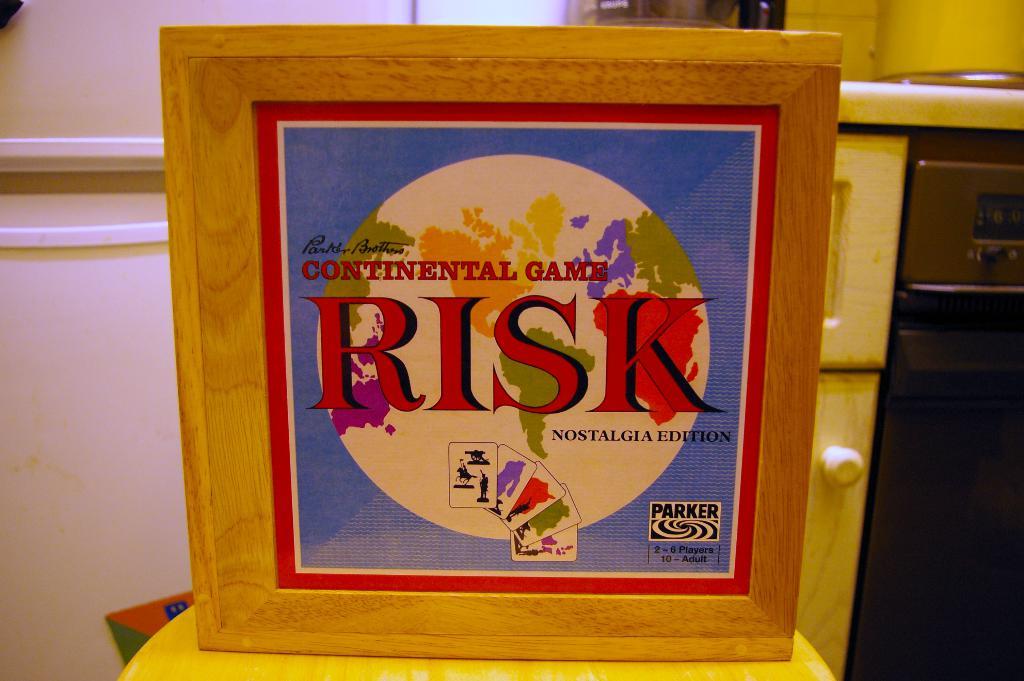What game is this?
Offer a terse response. Risk. Who makes the game risk?
Make the answer very short. Parker. 